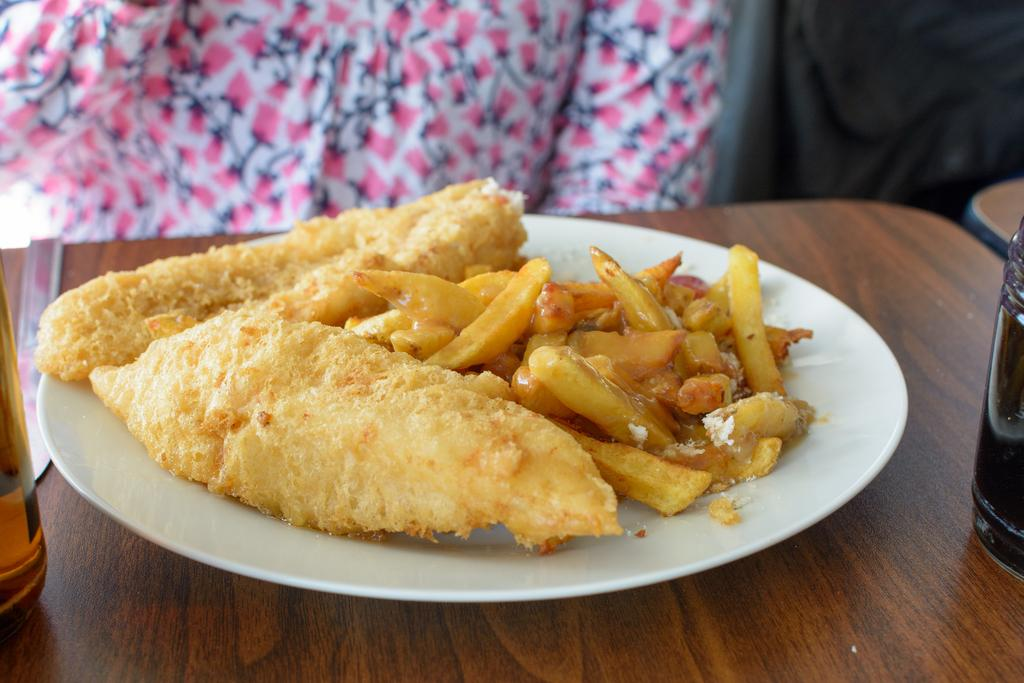What is on the plate that is visible in the image? There is food in a white plate in the image. What is the plate placed on? The plate is placed on a wooden table top. Who is present in the image? There is a woman in the image. What is the woman wearing? The woman is wearing a white and pink dress. What is the woman doing in the image? The woman is sitting on a chair. What type of worm can be seen crawling on the woman's dress in the image? There is no worm present in the image; the woman is wearing a white and pink dress while sitting on a chair. 